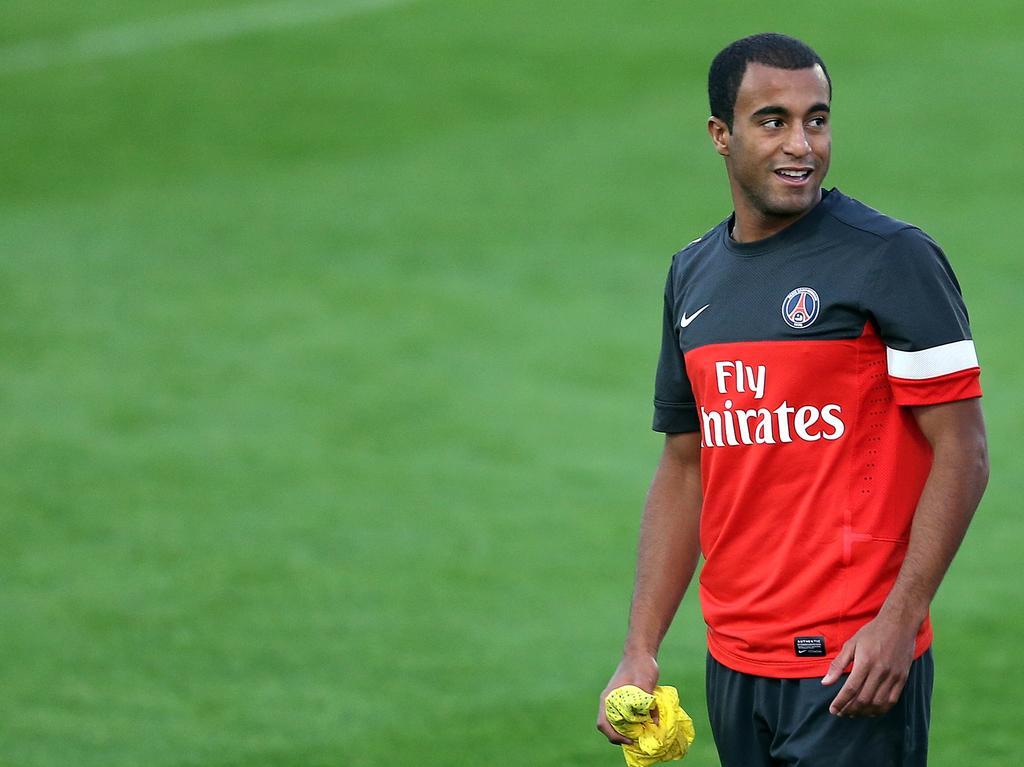Could you give a brief overview of what you see in this image? In this picture we can see a man holding a cloth in his hand. We can see some grass on the ground. 